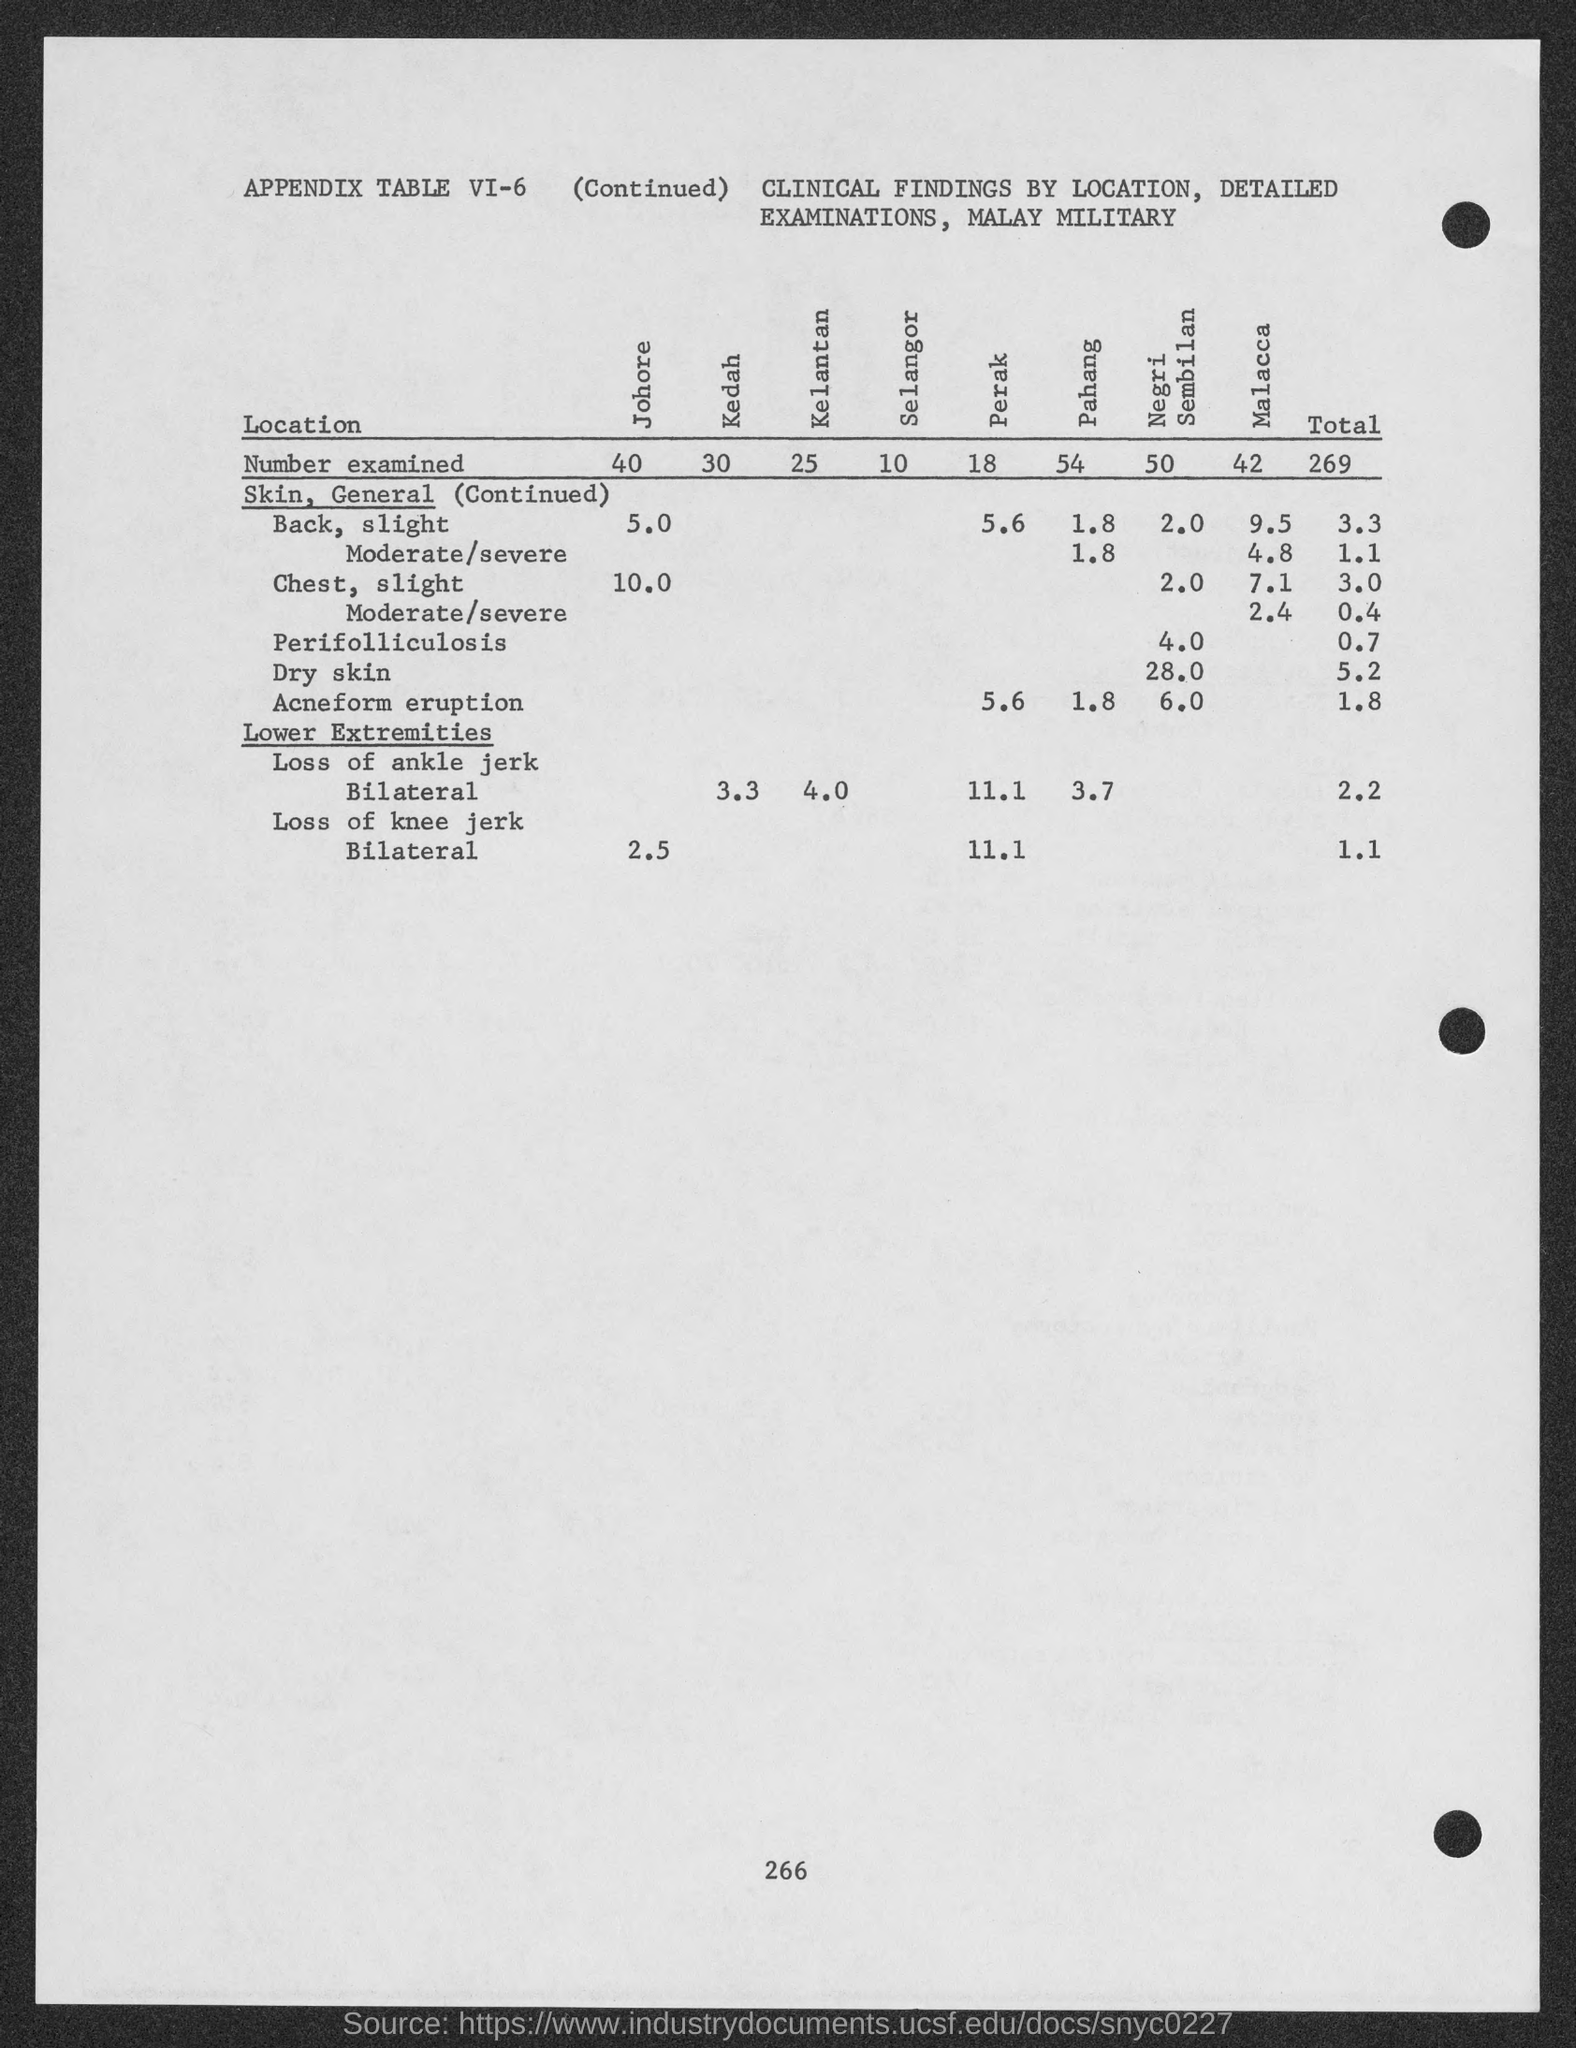What is the number at bottom of the page ?
Ensure brevity in your answer.  266. What is the total number examined ?
Offer a terse response. 269. What is the number examined in johore?
Offer a terse response. 40. What is the number examined in kedah?
Offer a terse response. 30. What is the number examined in kelantan?
Your answer should be very brief. 25. What is the number examined in selangor ?
Ensure brevity in your answer.  10. What is the number examined in perak?
Make the answer very short. 18. What is the number examined in pahang?
Provide a succinct answer. 54. What is the number examined in negri sembilan ?
Ensure brevity in your answer.  50. What is the number examined in malacca ?
Make the answer very short. 42. 